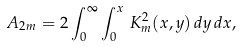Convert formula to latex. <formula><loc_0><loc_0><loc_500><loc_500>A _ { 2 m } = 2 \int _ { 0 } ^ { \infty } \int _ { 0 } ^ { x } \, K ^ { 2 } _ { m } ( x , y ) \, d y \, d x ,</formula> 